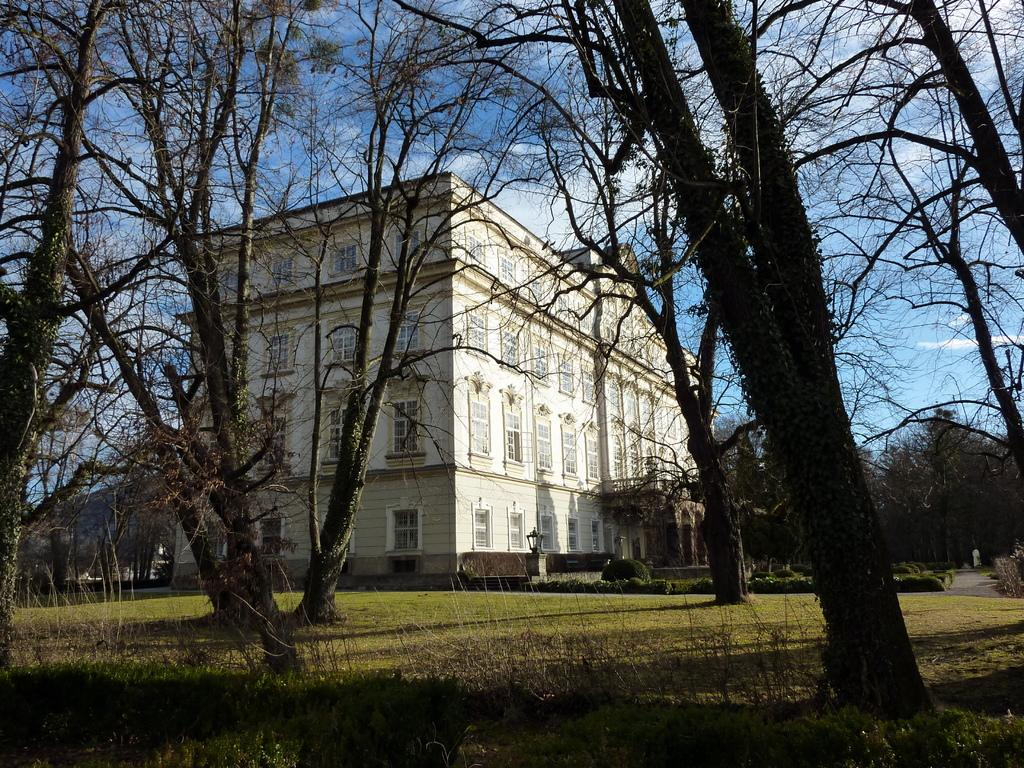What type of ground surface is visible in the image? There is grass on the ground in the image. What type of vegetation can be seen in the image? There are trees in the image. What can be seen in the background of the image? There is a building with a window and the sky is visible in the background. What is visible in the sky? Clouds are present in the sky. What type of vessel is being used to catch fish in the image? There is no vessel or fishing activity present in the image. What type of bait is being used to attract fish in the image? There is no fishing activity or bait present in the image. 